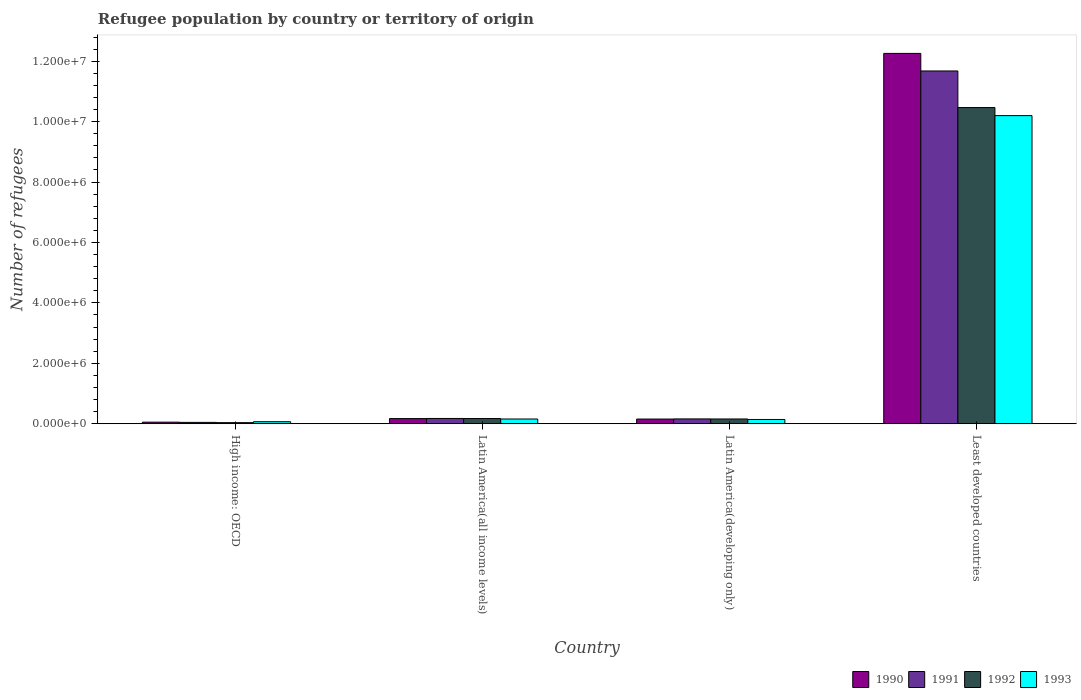How many different coloured bars are there?
Offer a very short reply. 4. How many groups of bars are there?
Ensure brevity in your answer.  4. How many bars are there on the 3rd tick from the left?
Offer a very short reply. 4. How many bars are there on the 4th tick from the right?
Keep it short and to the point. 4. What is the label of the 3rd group of bars from the left?
Offer a terse response. Latin America(developing only). What is the number of refugees in 1993 in Latin America(all income levels)?
Keep it short and to the point. 1.57e+05. Across all countries, what is the maximum number of refugees in 1991?
Your answer should be very brief. 1.17e+07. Across all countries, what is the minimum number of refugees in 1991?
Provide a succinct answer. 4.49e+04. In which country was the number of refugees in 1990 maximum?
Keep it short and to the point. Least developed countries. In which country was the number of refugees in 1990 minimum?
Offer a terse response. High income: OECD. What is the total number of refugees in 1990 in the graph?
Provide a succinct answer. 1.26e+07. What is the difference between the number of refugees in 1991 in Latin America(developing only) and that in Least developed countries?
Keep it short and to the point. -1.15e+07. What is the difference between the number of refugees in 1990 in Least developed countries and the number of refugees in 1993 in High income: OECD?
Provide a short and direct response. 1.22e+07. What is the average number of refugees in 1993 per country?
Your answer should be compact. 2.64e+06. What is the difference between the number of refugees of/in 1992 and number of refugees of/in 1991 in High income: OECD?
Ensure brevity in your answer.  -8926. What is the ratio of the number of refugees in 1993 in High income: OECD to that in Latin America(all income levels)?
Give a very brief answer. 0.43. Is the number of refugees in 1993 in High income: OECD less than that in Latin America(developing only)?
Your response must be concise. Yes. Is the difference between the number of refugees in 1992 in Latin America(all income levels) and Least developed countries greater than the difference between the number of refugees in 1991 in Latin America(all income levels) and Least developed countries?
Offer a very short reply. Yes. What is the difference between the highest and the second highest number of refugees in 1990?
Your response must be concise. 1.21e+07. What is the difference between the highest and the lowest number of refugees in 1991?
Keep it short and to the point. 1.16e+07. Is the sum of the number of refugees in 1991 in High income: OECD and Latin America(all income levels) greater than the maximum number of refugees in 1990 across all countries?
Your response must be concise. No. Is it the case that in every country, the sum of the number of refugees in 1990 and number of refugees in 1991 is greater than the sum of number of refugees in 1993 and number of refugees in 1992?
Offer a terse response. No. What does the 3rd bar from the left in Least developed countries represents?
Your answer should be compact. 1992. Is it the case that in every country, the sum of the number of refugees in 1990 and number of refugees in 1993 is greater than the number of refugees in 1991?
Give a very brief answer. Yes. Are all the bars in the graph horizontal?
Offer a very short reply. No. How many countries are there in the graph?
Give a very brief answer. 4. What is the difference between two consecutive major ticks on the Y-axis?
Your answer should be very brief. 2.00e+06. Does the graph contain any zero values?
Your response must be concise. No. How many legend labels are there?
Ensure brevity in your answer.  4. How are the legend labels stacked?
Provide a short and direct response. Horizontal. What is the title of the graph?
Your answer should be very brief. Refugee population by country or territory of origin. What is the label or title of the Y-axis?
Provide a succinct answer. Number of refugees. What is the Number of refugees in 1990 in High income: OECD?
Ensure brevity in your answer.  5.21e+04. What is the Number of refugees of 1991 in High income: OECD?
Your answer should be very brief. 4.49e+04. What is the Number of refugees of 1992 in High income: OECD?
Your answer should be compact. 3.60e+04. What is the Number of refugees of 1993 in High income: OECD?
Provide a succinct answer. 6.74e+04. What is the Number of refugees of 1990 in Latin America(all income levels)?
Keep it short and to the point. 1.71e+05. What is the Number of refugees of 1991 in Latin America(all income levels)?
Your answer should be compact. 1.75e+05. What is the Number of refugees in 1992 in Latin America(all income levels)?
Your response must be concise. 1.72e+05. What is the Number of refugees in 1993 in Latin America(all income levels)?
Your answer should be very brief. 1.57e+05. What is the Number of refugees of 1990 in Latin America(developing only)?
Your response must be concise. 1.55e+05. What is the Number of refugees in 1991 in Latin America(developing only)?
Make the answer very short. 1.60e+05. What is the Number of refugees in 1992 in Latin America(developing only)?
Your answer should be compact. 1.58e+05. What is the Number of refugees in 1993 in Latin America(developing only)?
Make the answer very short. 1.41e+05. What is the Number of refugees in 1990 in Least developed countries?
Ensure brevity in your answer.  1.23e+07. What is the Number of refugees of 1991 in Least developed countries?
Ensure brevity in your answer.  1.17e+07. What is the Number of refugees in 1992 in Least developed countries?
Your response must be concise. 1.05e+07. What is the Number of refugees in 1993 in Least developed countries?
Give a very brief answer. 1.02e+07. Across all countries, what is the maximum Number of refugees of 1990?
Keep it short and to the point. 1.23e+07. Across all countries, what is the maximum Number of refugees in 1991?
Your answer should be very brief. 1.17e+07. Across all countries, what is the maximum Number of refugees in 1992?
Keep it short and to the point. 1.05e+07. Across all countries, what is the maximum Number of refugees in 1993?
Provide a succinct answer. 1.02e+07. Across all countries, what is the minimum Number of refugees of 1990?
Keep it short and to the point. 5.21e+04. Across all countries, what is the minimum Number of refugees in 1991?
Ensure brevity in your answer.  4.49e+04. Across all countries, what is the minimum Number of refugees of 1992?
Offer a very short reply. 3.60e+04. Across all countries, what is the minimum Number of refugees in 1993?
Provide a short and direct response. 6.74e+04. What is the total Number of refugees of 1990 in the graph?
Provide a short and direct response. 1.26e+07. What is the total Number of refugees in 1991 in the graph?
Give a very brief answer. 1.21e+07. What is the total Number of refugees in 1992 in the graph?
Your answer should be compact. 1.08e+07. What is the total Number of refugees in 1993 in the graph?
Provide a short and direct response. 1.06e+07. What is the difference between the Number of refugees in 1990 in High income: OECD and that in Latin America(all income levels)?
Make the answer very short. -1.19e+05. What is the difference between the Number of refugees of 1991 in High income: OECD and that in Latin America(all income levels)?
Your answer should be very brief. -1.30e+05. What is the difference between the Number of refugees in 1992 in High income: OECD and that in Latin America(all income levels)?
Ensure brevity in your answer.  -1.36e+05. What is the difference between the Number of refugees of 1993 in High income: OECD and that in Latin America(all income levels)?
Keep it short and to the point. -8.92e+04. What is the difference between the Number of refugees in 1990 in High income: OECD and that in Latin America(developing only)?
Provide a succinct answer. -1.03e+05. What is the difference between the Number of refugees of 1991 in High income: OECD and that in Latin America(developing only)?
Provide a succinct answer. -1.15e+05. What is the difference between the Number of refugees in 1992 in High income: OECD and that in Latin America(developing only)?
Provide a short and direct response. -1.22e+05. What is the difference between the Number of refugees of 1993 in High income: OECD and that in Latin America(developing only)?
Provide a short and direct response. -7.35e+04. What is the difference between the Number of refugees in 1990 in High income: OECD and that in Least developed countries?
Give a very brief answer. -1.22e+07. What is the difference between the Number of refugees in 1991 in High income: OECD and that in Least developed countries?
Your answer should be very brief. -1.16e+07. What is the difference between the Number of refugees of 1992 in High income: OECD and that in Least developed countries?
Give a very brief answer. -1.04e+07. What is the difference between the Number of refugees in 1993 in High income: OECD and that in Least developed countries?
Ensure brevity in your answer.  -1.01e+07. What is the difference between the Number of refugees of 1990 in Latin America(all income levels) and that in Latin America(developing only)?
Make the answer very short. 1.57e+04. What is the difference between the Number of refugees in 1991 in Latin America(all income levels) and that in Latin America(developing only)?
Ensure brevity in your answer.  1.48e+04. What is the difference between the Number of refugees of 1992 in Latin America(all income levels) and that in Latin America(developing only)?
Your answer should be very brief. 1.46e+04. What is the difference between the Number of refugees in 1993 in Latin America(all income levels) and that in Latin America(developing only)?
Make the answer very short. 1.57e+04. What is the difference between the Number of refugees in 1990 in Latin America(all income levels) and that in Least developed countries?
Offer a terse response. -1.21e+07. What is the difference between the Number of refugees in 1991 in Latin America(all income levels) and that in Least developed countries?
Offer a very short reply. -1.15e+07. What is the difference between the Number of refugees of 1992 in Latin America(all income levels) and that in Least developed countries?
Give a very brief answer. -1.03e+07. What is the difference between the Number of refugees in 1993 in Latin America(all income levels) and that in Least developed countries?
Your answer should be very brief. -1.00e+07. What is the difference between the Number of refugees of 1990 in Latin America(developing only) and that in Least developed countries?
Ensure brevity in your answer.  -1.21e+07. What is the difference between the Number of refugees in 1991 in Latin America(developing only) and that in Least developed countries?
Your answer should be very brief. -1.15e+07. What is the difference between the Number of refugees of 1992 in Latin America(developing only) and that in Least developed countries?
Your response must be concise. -1.03e+07. What is the difference between the Number of refugees in 1993 in Latin America(developing only) and that in Least developed countries?
Provide a succinct answer. -1.01e+07. What is the difference between the Number of refugees in 1990 in High income: OECD and the Number of refugees in 1991 in Latin America(all income levels)?
Make the answer very short. -1.23e+05. What is the difference between the Number of refugees of 1990 in High income: OECD and the Number of refugees of 1992 in Latin America(all income levels)?
Offer a very short reply. -1.20e+05. What is the difference between the Number of refugees in 1990 in High income: OECD and the Number of refugees in 1993 in Latin America(all income levels)?
Your answer should be compact. -1.04e+05. What is the difference between the Number of refugees in 1991 in High income: OECD and the Number of refugees in 1992 in Latin America(all income levels)?
Keep it short and to the point. -1.27e+05. What is the difference between the Number of refugees in 1991 in High income: OECD and the Number of refugees in 1993 in Latin America(all income levels)?
Offer a terse response. -1.12e+05. What is the difference between the Number of refugees in 1992 in High income: OECD and the Number of refugees in 1993 in Latin America(all income levels)?
Your response must be concise. -1.21e+05. What is the difference between the Number of refugees in 1990 in High income: OECD and the Number of refugees in 1991 in Latin America(developing only)?
Your response must be concise. -1.08e+05. What is the difference between the Number of refugees of 1990 in High income: OECD and the Number of refugees of 1992 in Latin America(developing only)?
Make the answer very short. -1.06e+05. What is the difference between the Number of refugees in 1990 in High income: OECD and the Number of refugees in 1993 in Latin America(developing only)?
Provide a succinct answer. -8.88e+04. What is the difference between the Number of refugees in 1991 in High income: OECD and the Number of refugees in 1992 in Latin America(developing only)?
Your response must be concise. -1.13e+05. What is the difference between the Number of refugees in 1991 in High income: OECD and the Number of refugees in 1993 in Latin America(developing only)?
Keep it short and to the point. -9.59e+04. What is the difference between the Number of refugees in 1992 in High income: OECD and the Number of refugees in 1993 in Latin America(developing only)?
Offer a very short reply. -1.05e+05. What is the difference between the Number of refugees of 1990 in High income: OECD and the Number of refugees of 1991 in Least developed countries?
Give a very brief answer. -1.16e+07. What is the difference between the Number of refugees in 1990 in High income: OECD and the Number of refugees in 1992 in Least developed countries?
Make the answer very short. -1.04e+07. What is the difference between the Number of refugees in 1990 in High income: OECD and the Number of refugees in 1993 in Least developed countries?
Your answer should be compact. -1.01e+07. What is the difference between the Number of refugees in 1991 in High income: OECD and the Number of refugees in 1992 in Least developed countries?
Ensure brevity in your answer.  -1.04e+07. What is the difference between the Number of refugees in 1991 in High income: OECD and the Number of refugees in 1993 in Least developed countries?
Your response must be concise. -1.02e+07. What is the difference between the Number of refugees of 1992 in High income: OECD and the Number of refugees of 1993 in Least developed countries?
Ensure brevity in your answer.  -1.02e+07. What is the difference between the Number of refugees of 1990 in Latin America(all income levels) and the Number of refugees of 1991 in Latin America(developing only)?
Your answer should be compact. 1.09e+04. What is the difference between the Number of refugees of 1990 in Latin America(all income levels) and the Number of refugees of 1992 in Latin America(developing only)?
Your answer should be compact. 1.30e+04. What is the difference between the Number of refugees in 1990 in Latin America(all income levels) and the Number of refugees in 1993 in Latin America(developing only)?
Keep it short and to the point. 2.99e+04. What is the difference between the Number of refugees of 1991 in Latin America(all income levels) and the Number of refugees of 1992 in Latin America(developing only)?
Your answer should be very brief. 1.69e+04. What is the difference between the Number of refugees in 1991 in Latin America(all income levels) and the Number of refugees in 1993 in Latin America(developing only)?
Provide a short and direct response. 3.38e+04. What is the difference between the Number of refugees in 1992 in Latin America(all income levels) and the Number of refugees in 1993 in Latin America(developing only)?
Your answer should be very brief. 3.15e+04. What is the difference between the Number of refugees in 1990 in Latin America(all income levels) and the Number of refugees in 1991 in Least developed countries?
Your answer should be compact. -1.15e+07. What is the difference between the Number of refugees of 1990 in Latin America(all income levels) and the Number of refugees of 1992 in Least developed countries?
Make the answer very short. -1.03e+07. What is the difference between the Number of refugees of 1990 in Latin America(all income levels) and the Number of refugees of 1993 in Least developed countries?
Offer a terse response. -1.00e+07. What is the difference between the Number of refugees of 1991 in Latin America(all income levels) and the Number of refugees of 1992 in Least developed countries?
Offer a very short reply. -1.03e+07. What is the difference between the Number of refugees in 1991 in Latin America(all income levels) and the Number of refugees in 1993 in Least developed countries?
Make the answer very short. -1.00e+07. What is the difference between the Number of refugees of 1992 in Latin America(all income levels) and the Number of refugees of 1993 in Least developed countries?
Your answer should be very brief. -1.00e+07. What is the difference between the Number of refugees of 1990 in Latin America(developing only) and the Number of refugees of 1991 in Least developed countries?
Keep it short and to the point. -1.15e+07. What is the difference between the Number of refugees in 1990 in Latin America(developing only) and the Number of refugees in 1992 in Least developed countries?
Provide a short and direct response. -1.03e+07. What is the difference between the Number of refugees of 1990 in Latin America(developing only) and the Number of refugees of 1993 in Least developed countries?
Your answer should be compact. -1.00e+07. What is the difference between the Number of refugees of 1991 in Latin America(developing only) and the Number of refugees of 1992 in Least developed countries?
Your response must be concise. -1.03e+07. What is the difference between the Number of refugees of 1991 in Latin America(developing only) and the Number of refugees of 1993 in Least developed countries?
Your response must be concise. -1.00e+07. What is the difference between the Number of refugees of 1992 in Latin America(developing only) and the Number of refugees of 1993 in Least developed countries?
Offer a terse response. -1.00e+07. What is the average Number of refugees of 1990 per country?
Your answer should be compact. 3.16e+06. What is the average Number of refugees in 1991 per country?
Your response must be concise. 3.01e+06. What is the average Number of refugees in 1992 per country?
Keep it short and to the point. 2.71e+06. What is the average Number of refugees in 1993 per country?
Your answer should be very brief. 2.64e+06. What is the difference between the Number of refugees in 1990 and Number of refugees in 1991 in High income: OECD?
Offer a very short reply. 7172. What is the difference between the Number of refugees of 1990 and Number of refugees of 1992 in High income: OECD?
Ensure brevity in your answer.  1.61e+04. What is the difference between the Number of refugees of 1990 and Number of refugees of 1993 in High income: OECD?
Ensure brevity in your answer.  -1.53e+04. What is the difference between the Number of refugees in 1991 and Number of refugees in 1992 in High income: OECD?
Offer a terse response. 8926. What is the difference between the Number of refugees of 1991 and Number of refugees of 1993 in High income: OECD?
Give a very brief answer. -2.24e+04. What is the difference between the Number of refugees in 1992 and Number of refugees in 1993 in High income: OECD?
Provide a succinct answer. -3.14e+04. What is the difference between the Number of refugees in 1990 and Number of refugees in 1991 in Latin America(all income levels)?
Give a very brief answer. -3867. What is the difference between the Number of refugees in 1990 and Number of refugees in 1992 in Latin America(all income levels)?
Ensure brevity in your answer.  -1569. What is the difference between the Number of refugees in 1990 and Number of refugees in 1993 in Latin America(all income levels)?
Provide a short and direct response. 1.42e+04. What is the difference between the Number of refugees of 1991 and Number of refugees of 1992 in Latin America(all income levels)?
Make the answer very short. 2298. What is the difference between the Number of refugees in 1991 and Number of refugees in 1993 in Latin America(all income levels)?
Your response must be concise. 1.81e+04. What is the difference between the Number of refugees of 1992 and Number of refugees of 1993 in Latin America(all income levels)?
Ensure brevity in your answer.  1.58e+04. What is the difference between the Number of refugees of 1990 and Number of refugees of 1991 in Latin America(developing only)?
Your answer should be very brief. -4784. What is the difference between the Number of refugees in 1990 and Number of refugees in 1992 in Latin America(developing only)?
Make the answer very short. -2704. What is the difference between the Number of refugees in 1990 and Number of refugees in 1993 in Latin America(developing only)?
Give a very brief answer. 1.42e+04. What is the difference between the Number of refugees of 1991 and Number of refugees of 1992 in Latin America(developing only)?
Give a very brief answer. 2080. What is the difference between the Number of refugees in 1991 and Number of refugees in 1993 in Latin America(developing only)?
Ensure brevity in your answer.  1.89e+04. What is the difference between the Number of refugees of 1992 and Number of refugees of 1993 in Latin America(developing only)?
Give a very brief answer. 1.69e+04. What is the difference between the Number of refugees of 1990 and Number of refugees of 1991 in Least developed countries?
Your response must be concise. 5.82e+05. What is the difference between the Number of refugees in 1990 and Number of refugees in 1992 in Least developed countries?
Give a very brief answer. 1.79e+06. What is the difference between the Number of refugees in 1990 and Number of refugees in 1993 in Least developed countries?
Offer a terse response. 2.06e+06. What is the difference between the Number of refugees in 1991 and Number of refugees in 1992 in Least developed countries?
Your response must be concise. 1.21e+06. What is the difference between the Number of refugees of 1991 and Number of refugees of 1993 in Least developed countries?
Give a very brief answer. 1.48e+06. What is the difference between the Number of refugees of 1992 and Number of refugees of 1993 in Least developed countries?
Offer a terse response. 2.67e+05. What is the ratio of the Number of refugees of 1990 in High income: OECD to that in Latin America(all income levels)?
Give a very brief answer. 0.31. What is the ratio of the Number of refugees of 1991 in High income: OECD to that in Latin America(all income levels)?
Provide a succinct answer. 0.26. What is the ratio of the Number of refugees in 1992 in High income: OECD to that in Latin America(all income levels)?
Your answer should be compact. 0.21. What is the ratio of the Number of refugees in 1993 in High income: OECD to that in Latin America(all income levels)?
Keep it short and to the point. 0.43. What is the ratio of the Number of refugees in 1990 in High income: OECD to that in Latin America(developing only)?
Your answer should be very brief. 0.34. What is the ratio of the Number of refugees in 1991 in High income: OECD to that in Latin America(developing only)?
Your response must be concise. 0.28. What is the ratio of the Number of refugees of 1992 in High income: OECD to that in Latin America(developing only)?
Your response must be concise. 0.23. What is the ratio of the Number of refugees of 1993 in High income: OECD to that in Latin America(developing only)?
Give a very brief answer. 0.48. What is the ratio of the Number of refugees of 1990 in High income: OECD to that in Least developed countries?
Give a very brief answer. 0. What is the ratio of the Number of refugees in 1991 in High income: OECD to that in Least developed countries?
Give a very brief answer. 0. What is the ratio of the Number of refugees in 1992 in High income: OECD to that in Least developed countries?
Offer a very short reply. 0. What is the ratio of the Number of refugees in 1993 in High income: OECD to that in Least developed countries?
Provide a succinct answer. 0.01. What is the ratio of the Number of refugees in 1990 in Latin America(all income levels) to that in Latin America(developing only)?
Give a very brief answer. 1.1. What is the ratio of the Number of refugees in 1991 in Latin America(all income levels) to that in Latin America(developing only)?
Your answer should be compact. 1.09. What is the ratio of the Number of refugees in 1992 in Latin America(all income levels) to that in Latin America(developing only)?
Offer a terse response. 1.09. What is the ratio of the Number of refugees of 1993 in Latin America(all income levels) to that in Latin America(developing only)?
Give a very brief answer. 1.11. What is the ratio of the Number of refugees of 1990 in Latin America(all income levels) to that in Least developed countries?
Your answer should be very brief. 0.01. What is the ratio of the Number of refugees of 1991 in Latin America(all income levels) to that in Least developed countries?
Give a very brief answer. 0.01. What is the ratio of the Number of refugees of 1992 in Latin America(all income levels) to that in Least developed countries?
Give a very brief answer. 0.02. What is the ratio of the Number of refugees in 1993 in Latin America(all income levels) to that in Least developed countries?
Make the answer very short. 0.02. What is the ratio of the Number of refugees in 1990 in Latin America(developing only) to that in Least developed countries?
Provide a succinct answer. 0.01. What is the ratio of the Number of refugees of 1991 in Latin America(developing only) to that in Least developed countries?
Offer a terse response. 0.01. What is the ratio of the Number of refugees of 1992 in Latin America(developing only) to that in Least developed countries?
Give a very brief answer. 0.02. What is the ratio of the Number of refugees of 1993 in Latin America(developing only) to that in Least developed countries?
Your answer should be compact. 0.01. What is the difference between the highest and the second highest Number of refugees of 1990?
Give a very brief answer. 1.21e+07. What is the difference between the highest and the second highest Number of refugees of 1991?
Keep it short and to the point. 1.15e+07. What is the difference between the highest and the second highest Number of refugees in 1992?
Keep it short and to the point. 1.03e+07. What is the difference between the highest and the second highest Number of refugees in 1993?
Your answer should be compact. 1.00e+07. What is the difference between the highest and the lowest Number of refugees in 1990?
Your answer should be very brief. 1.22e+07. What is the difference between the highest and the lowest Number of refugees in 1991?
Your response must be concise. 1.16e+07. What is the difference between the highest and the lowest Number of refugees in 1992?
Provide a succinct answer. 1.04e+07. What is the difference between the highest and the lowest Number of refugees in 1993?
Provide a succinct answer. 1.01e+07. 